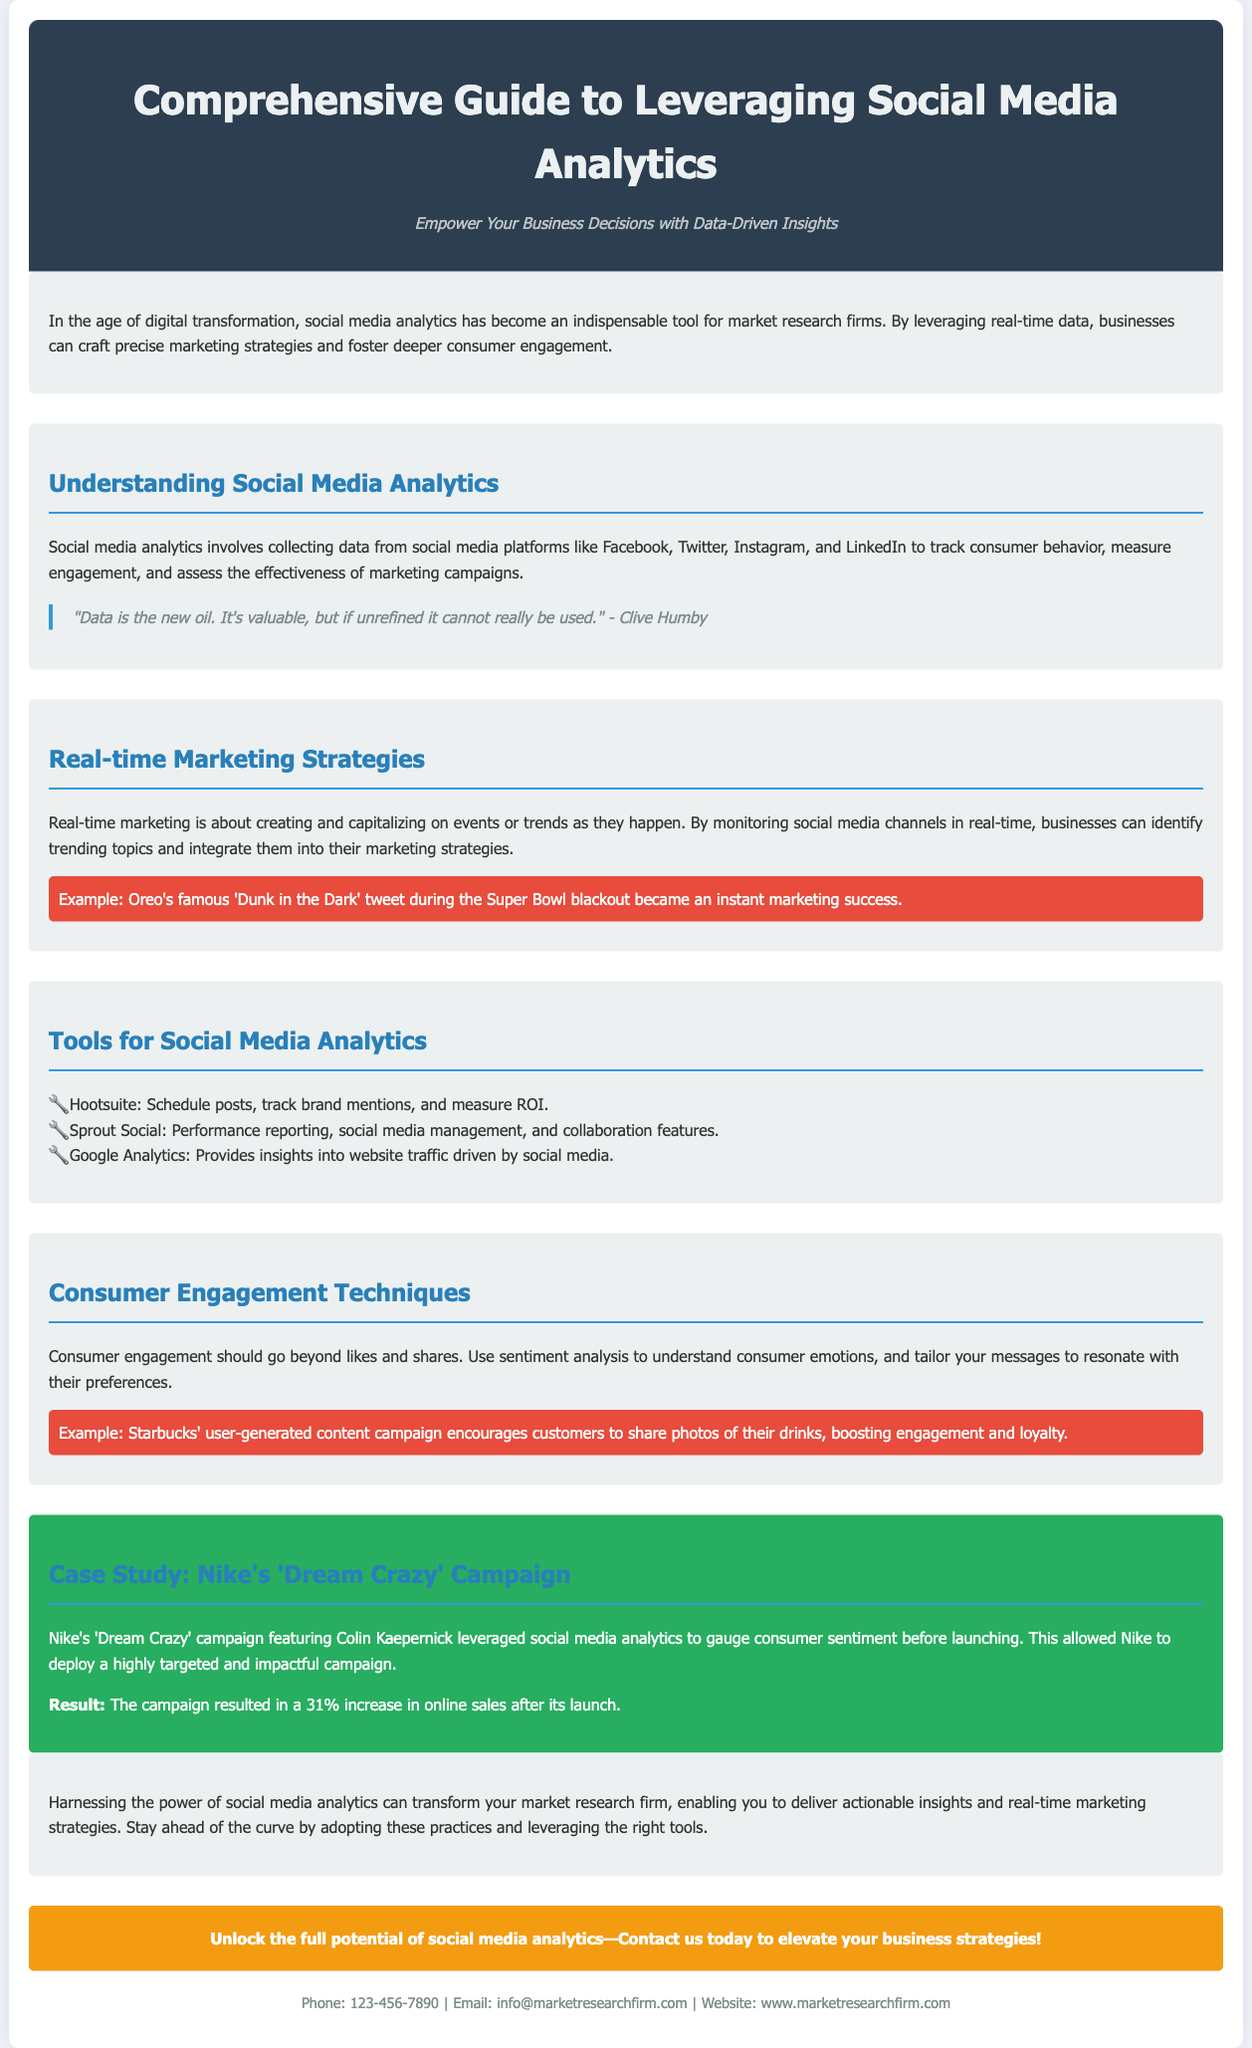What is the title of the guide? The title is explicitly stated in the header section of the document.
Answer: Comprehensive Guide to Leveraging Social Media Analytics What are the main social media platforms mentioned? The document lists specific platforms where data is collected for analysis.
Answer: Facebook, Twitter, Instagram, LinkedIn What was the result of Nike's 'Dream Crazy' campaign? The result mentioned in the case study section highlights a significant change post-campaign.
Answer: 31% increase in online sales Which tool is mentioned for measuring ROI? The document lists tools for social media analytics, specifying one that tracks brand mentions and measures ROI.
Answer: Hootsuite What is a key strategy for real-time marketing? The section discusses the importance of monitoring social media channels for immediate actions.
Answer: Identify trending topics What quote is included in the document? A quote is highlighted to emphasize the value of data, which reflects a common sentiment about analytics.
Answer: "Data is the new oil. It's valuable, but if unrefined it cannot really be used." - Clive Humby How can businesses engage consumers beyond likes and shares? The document suggests a specific technique to enhance consumer interaction.
Answer: Use sentiment analysis What is the contact email provided for the market research firm? The contact section contains the email address for inquiries.
Answer: info@marketresearchfirm.com 